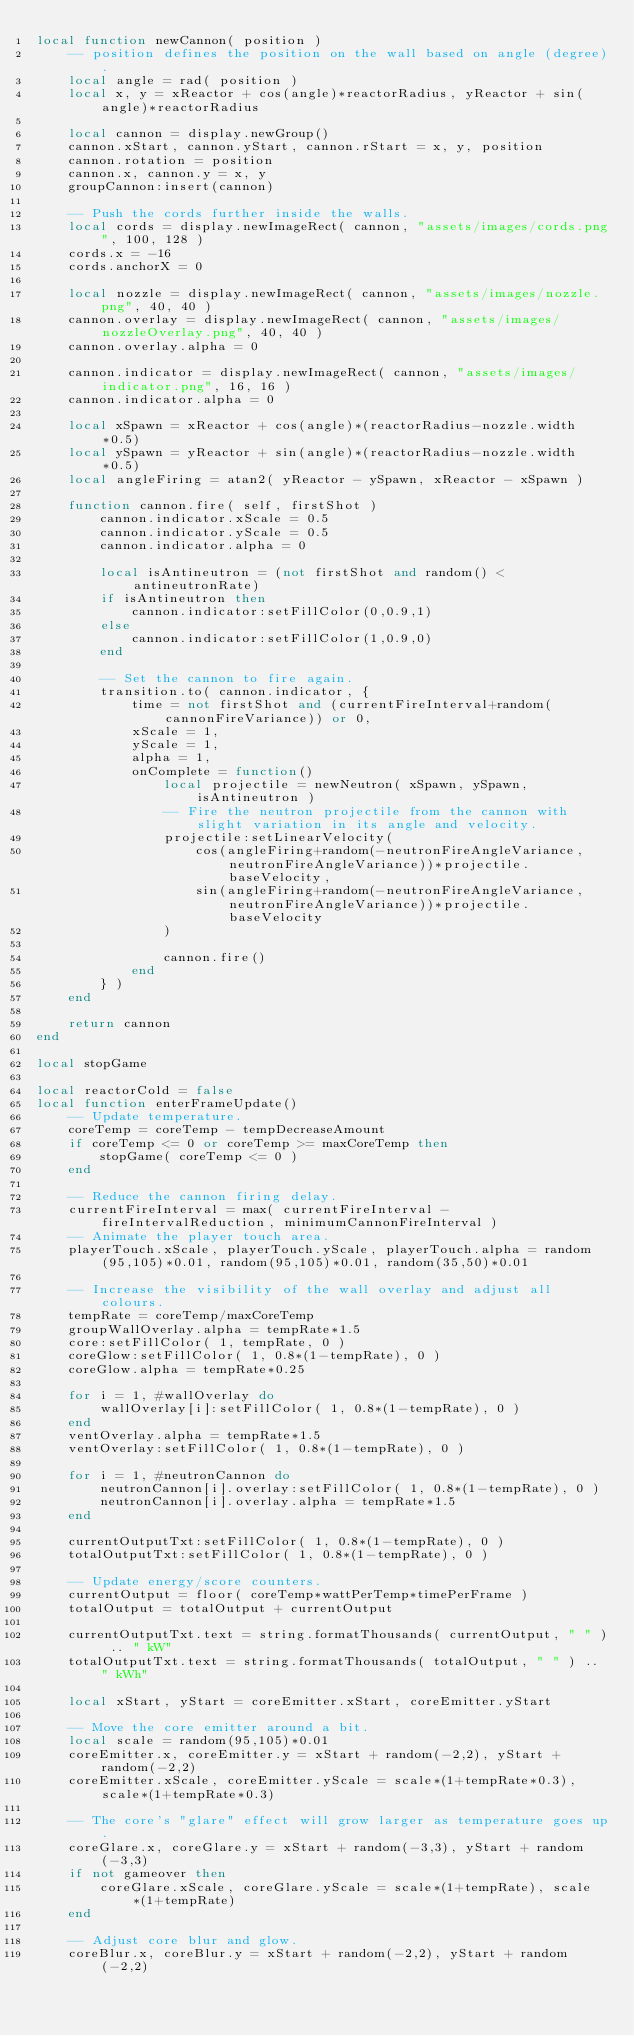<code> <loc_0><loc_0><loc_500><loc_500><_Lua_>local function newCannon( position )
    -- position defines the position on the wall based on angle (degree).
    local angle = rad( position )
    local x, y = xReactor + cos(angle)*reactorRadius, yReactor + sin(angle)*reactorRadius
    
    local cannon = display.newGroup()
    cannon.xStart, cannon.yStart, cannon.rStart = x, y, position
    cannon.rotation = position
    cannon.x, cannon.y = x, y
    groupCannon:insert(cannon)
    
    -- Push the cords further inside the walls.
    local cords = display.newImageRect( cannon, "assets/images/cords.png", 100, 128 )
    cords.x = -16
    cords.anchorX = 0
    
    local nozzle = display.newImageRect( cannon, "assets/images/nozzle.png", 40, 40 )
    cannon.overlay = display.newImageRect( cannon, "assets/images/nozzleOverlay.png", 40, 40 )
    cannon.overlay.alpha = 0
    
    cannon.indicator = display.newImageRect( cannon, "assets/images/indicator.png", 16, 16 )
    cannon.indicator.alpha = 0
    
    local xSpawn = xReactor + cos(angle)*(reactorRadius-nozzle.width*0.5)
    local ySpawn = yReactor + sin(angle)*(reactorRadius-nozzle.width*0.5)
    local angleFiring = atan2( yReactor - ySpawn, xReactor - xSpawn )
    
    function cannon.fire( self, firstShot )
        cannon.indicator.xScale = 0.5
        cannon.indicator.yScale = 0.5
        cannon.indicator.alpha = 0
        
        local isAntineutron = (not firstShot and random() < antineutronRate)
        if isAntineutron then
            cannon.indicator:setFillColor(0,0.9,1)
        else
            cannon.indicator:setFillColor(1,0.9,0)
        end
        
        -- Set the cannon to fire again.
        transition.to( cannon.indicator, {
            time = not firstShot and (currentFireInterval+random(cannonFireVariance)) or 0,
            xScale = 1,
            yScale = 1,
            alpha = 1,
            onComplete = function()
                local projectile = newNeutron( xSpawn, ySpawn, isAntineutron )
                -- Fire the neutron projectile from the cannon with slight variation in its angle and velocity.
                projectile:setLinearVelocity(
                    cos(angleFiring+random(-neutronFireAngleVariance,neutronFireAngleVariance))*projectile.baseVelocity,
                    sin(angleFiring+random(-neutronFireAngleVariance,neutronFireAngleVariance))*projectile.baseVelocity
                )
                
                cannon.fire()
            end 
        } )
    end
    
    return cannon
end

local stopGame

local reactorCold = false
local function enterFrameUpdate()
    -- Update temperature.
    coreTemp = coreTemp - tempDecreaseAmount
    if coreTemp <= 0 or coreTemp >= maxCoreTemp then
        stopGame( coreTemp <= 0 )
    end
    
    -- Reduce the cannon firing delay.
    currentFireInterval = max( currentFireInterval - fireIntervalReduction, minimumCannonFireInterval )
    -- Animate the player touch area.
    playerTouch.xScale, playerTouch.yScale, playerTouch.alpha = random(95,105)*0.01, random(95,105)*0.01, random(35,50)*0.01
    
    -- Increase the visibility of the wall overlay and adjust all colours.
    tempRate = coreTemp/maxCoreTemp
    groupWallOverlay.alpha = tempRate*1.5
    core:setFillColor( 1, tempRate, 0 )
    coreGlow:setFillColor( 1, 0.8*(1-tempRate), 0 )
    coreGlow.alpha = tempRate*0.25
    
    for i = 1, #wallOverlay do
        wallOverlay[i]:setFillColor( 1, 0.8*(1-tempRate), 0 )
    end
    ventOverlay.alpha = tempRate*1.5
    ventOverlay:setFillColor( 1, 0.8*(1-tempRate), 0 )
    
    for i = 1, #neutronCannon do
        neutronCannon[i].overlay:setFillColor( 1, 0.8*(1-tempRate), 0 )
        neutronCannon[i].overlay.alpha = tempRate*1.5
    end
    
    currentOutputTxt:setFillColor( 1, 0.8*(1-tempRate), 0 )
    totalOutputTxt:setFillColor( 1, 0.8*(1-tempRate), 0 )
    
    -- Update energy/score counters.
    currentOutput = floor( coreTemp*wattPerTemp*timePerFrame )
    totalOutput = totalOutput + currentOutput

    currentOutputTxt.text = string.formatThousands( currentOutput, " " ) .. " kW"
    totalOutputTxt.text = string.formatThousands( totalOutput, " " ) .. " kWh"

    local xStart, yStart = coreEmitter.xStart, coreEmitter.yStart
    
    -- Move the core emitter around a bit.
    local scale = random(95,105)*0.01
    coreEmitter.x, coreEmitter.y = xStart + random(-2,2), yStart + random(-2,2)
    coreEmitter.xScale, coreEmitter.yScale = scale*(1+tempRate*0.3), scale*(1+tempRate*0.3)
    
    -- The core's "glare" effect will grow larger as temperature goes up.
    coreGlare.x, coreGlare.y = xStart + random(-3,3), yStart + random(-3,3)
    if not gameover then
        coreGlare.xScale, coreGlare.yScale = scale*(1+tempRate), scale*(1+tempRate)
    end
    
    -- Adjust core blur and glow.
    coreBlur.x, coreBlur.y = xStart + random(-2,2), yStart + random(-2,2)</code> 